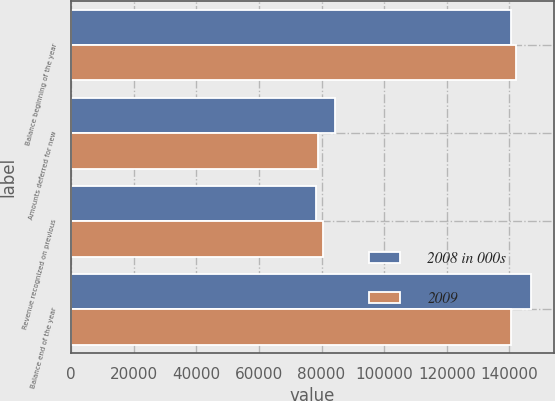<chart> <loc_0><loc_0><loc_500><loc_500><stacked_bar_chart><ecel><fcel>Balance beginning of the year<fcel>Amounts deferred for new<fcel>Revenue recognized on previous<fcel>Balance end of the year<nl><fcel>2008 in 000s<fcel>140583<fcel>84429<fcel>78205<fcel>146807<nl><fcel>2009<fcel>142173<fcel>78913<fcel>80503<fcel>140583<nl></chart> 